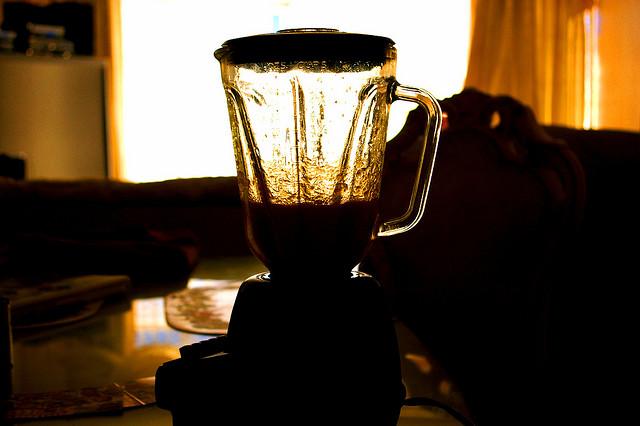Where is this picture taken?
Concise answer only. Kitchen. Is the blender full?
Keep it brief. No. What was the blender used for?
Keep it brief. Blending. 